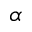<formula> <loc_0><loc_0><loc_500><loc_500>\alpha</formula> 